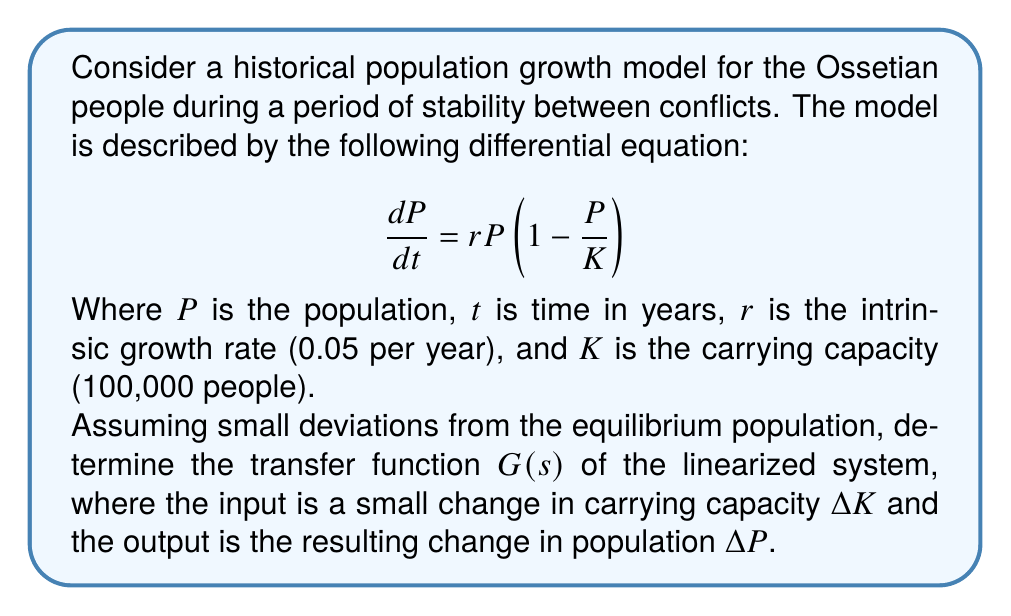What is the answer to this math problem? To solve this problem, we'll follow these steps:

1) First, we need to find the equilibrium point. At equilibrium, $\frac{dP}{dt} = 0$:

   $$0 = rP_{eq}(1 - \frac{P_{eq}}{K})$$

   Solving this, we get $P_{eq} = K = 100,000$.

2) Now, we linearize the system around this equilibrium point. Let $p = P - P_{eq}$ and $k = K - K_{eq}$. The linearized equation is:

   $$\frac{dp}{dt} = r(1 - \frac{2P_{eq}}{K})p + \frac{rP_{eq}}{K}k$$

3) Substituting the values:

   $$\frac{dp}{dt} = r(1 - 2)p + rk = -rp + rk = -0.05p + 0.05k$$

4) Taking the Laplace transform of both sides:

   $$sP(s) = -0.05P(s) + 0.05K(s)$$

5) Rearranging to get the transfer function $G(s) = \frac{P(s)}{K(s)}$:

   $$P(s)(s + 0.05) = 0.05K(s)$$
   $$\frac{P(s)}{K(s)} = \frac{0.05}{s + 0.05}$$

Thus, the transfer function $G(s) = \frac{0.05}{s + 0.05}$.
Answer: $G(s) = \frac{0.05}{s + 0.05}$ 